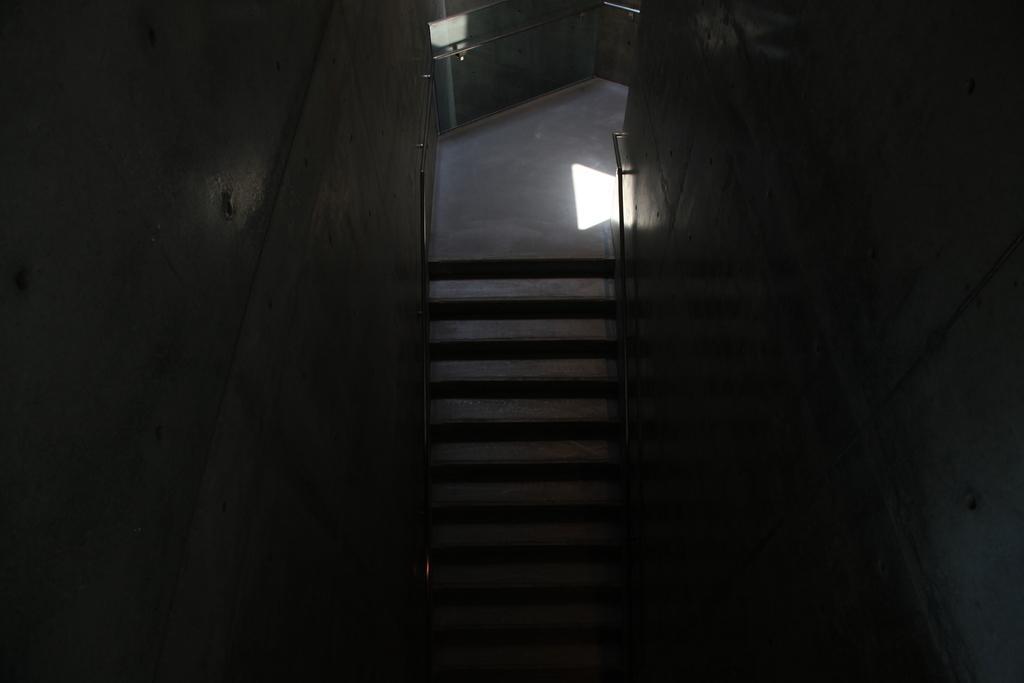Can you describe this image briefly? In the image we can see some steps and wall. 